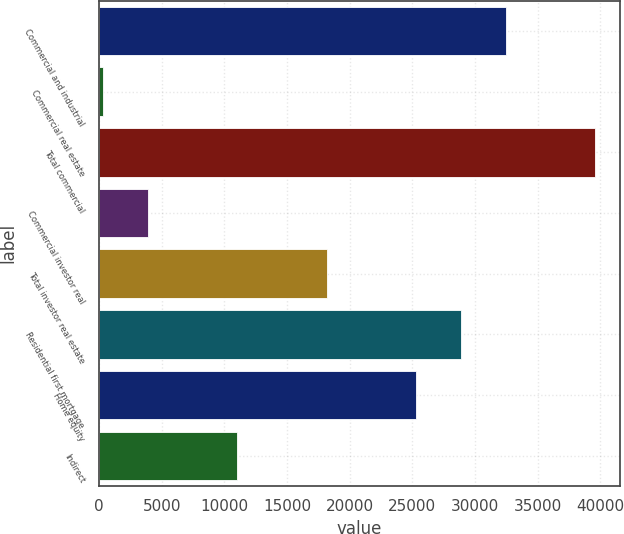Convert chart to OTSL. <chart><loc_0><loc_0><loc_500><loc_500><bar_chart><fcel>Commercial and industrial<fcel>Commercial real estate<fcel>Total commercial<fcel>Commercial investor real<fcel>Total investor real estate<fcel>Residential first mortgage<fcel>Home equity<fcel>Indirect<nl><fcel>32456.2<fcel>337<fcel>39593.8<fcel>3905.8<fcel>18181<fcel>28887.4<fcel>25318.6<fcel>11043.4<nl></chart> 